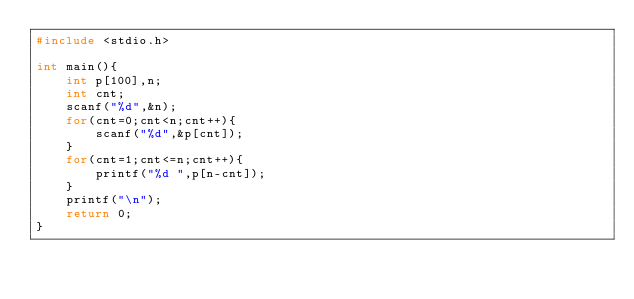<code> <loc_0><loc_0><loc_500><loc_500><_C_>#include <stdio.h>

int main(){
	int p[100],n;
	int cnt;
	scanf("%d",&n);
	for(cnt=0;cnt<n;cnt++){
		scanf("%d",&p[cnt]);
	}
	for(cnt=1;cnt<=n;cnt++){
		printf("%d ",p[n-cnt]);
	}
	printf("\n");
	return 0;
}</code> 